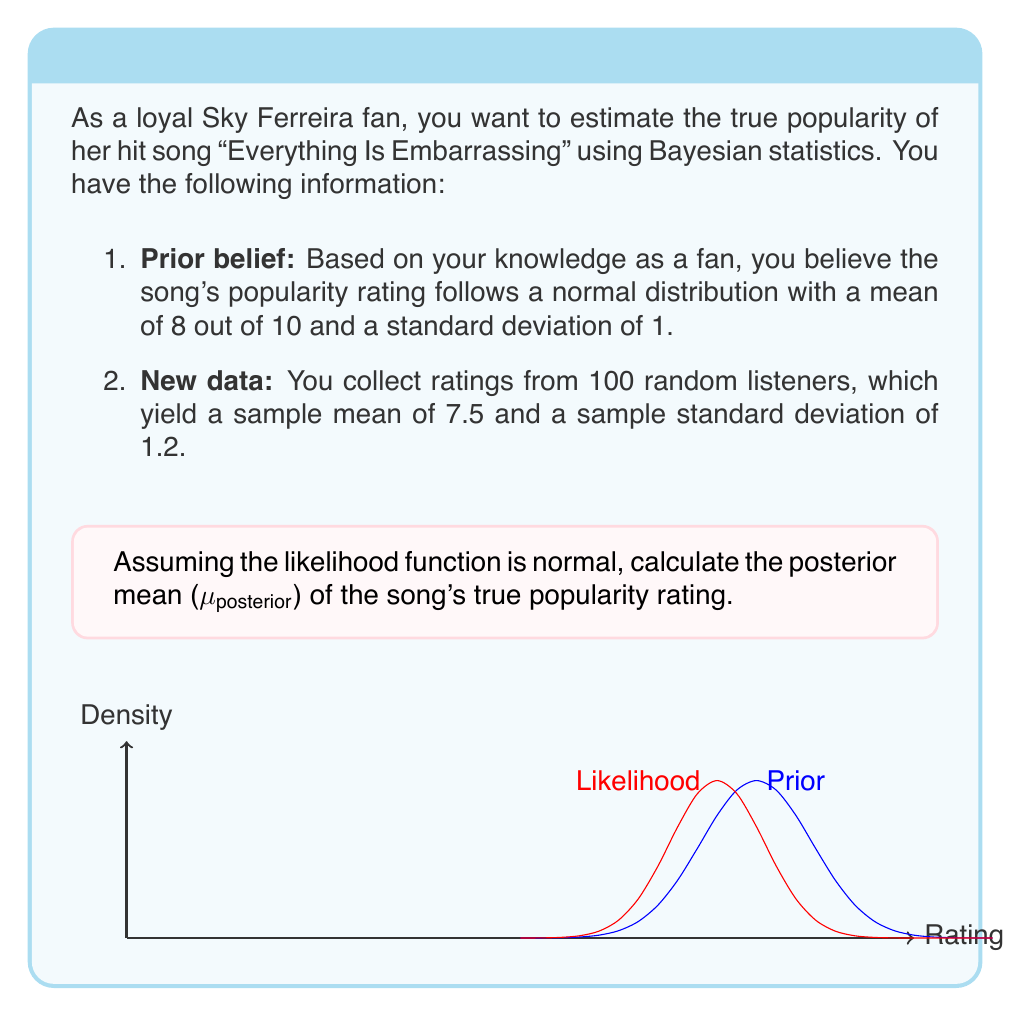Could you help me with this problem? To solve this problem, we'll use the Bayesian update formula for conjugate normal distributions. The steps are as follows:

1. Identify the prior distribution:
   μ_prior = 8
   σ²_prior = 1² = 1

2. Identify the likelihood (sample data):
   n = 100 (sample size)
   x̄ = 7.5 (sample mean)
   s² = 1.2² = 1.44 (sample variance)

3. Calculate the posterior mean using the formula:

   $$\mu_{posterior} = \frac{\frac{\mu_{prior}}{\sigma^2_{prior}} + \frac{n\bar{x}}{s^2}}{\frac{1}{\sigma^2_{prior}} + \frac{n}{s^2}}$$

4. Substitute the values:

   $$\mu_{posterior} = \frac{\frac{8}{1} + \frac{100 \cdot 7.5}{1.44}}{\frac{1}{1} + \frac{100}{1.44}}$$

5. Simplify:

   $$\mu_{posterior} = \frac{8 + 520.83}{1 + 69.44}$$

   $$\mu_{posterior} = \frac{528.83}{70.44}$$

6. Calculate the final result:

   $$\mu_{posterior} \approx 7.51$$

Therefore, the posterior mean of Sky Ferreira's "Everything Is Embarrassing" true popularity rating is approximately 7.51 out of 10.
Answer: 7.51 